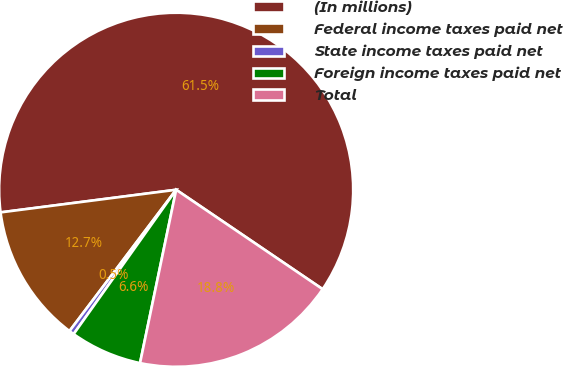Convert chart. <chart><loc_0><loc_0><loc_500><loc_500><pie_chart><fcel>(In millions)<fcel>Federal income taxes paid net<fcel>State income taxes paid net<fcel>Foreign income taxes paid net<fcel>Total<nl><fcel>61.53%<fcel>12.67%<fcel>0.46%<fcel>6.56%<fcel>18.78%<nl></chart> 